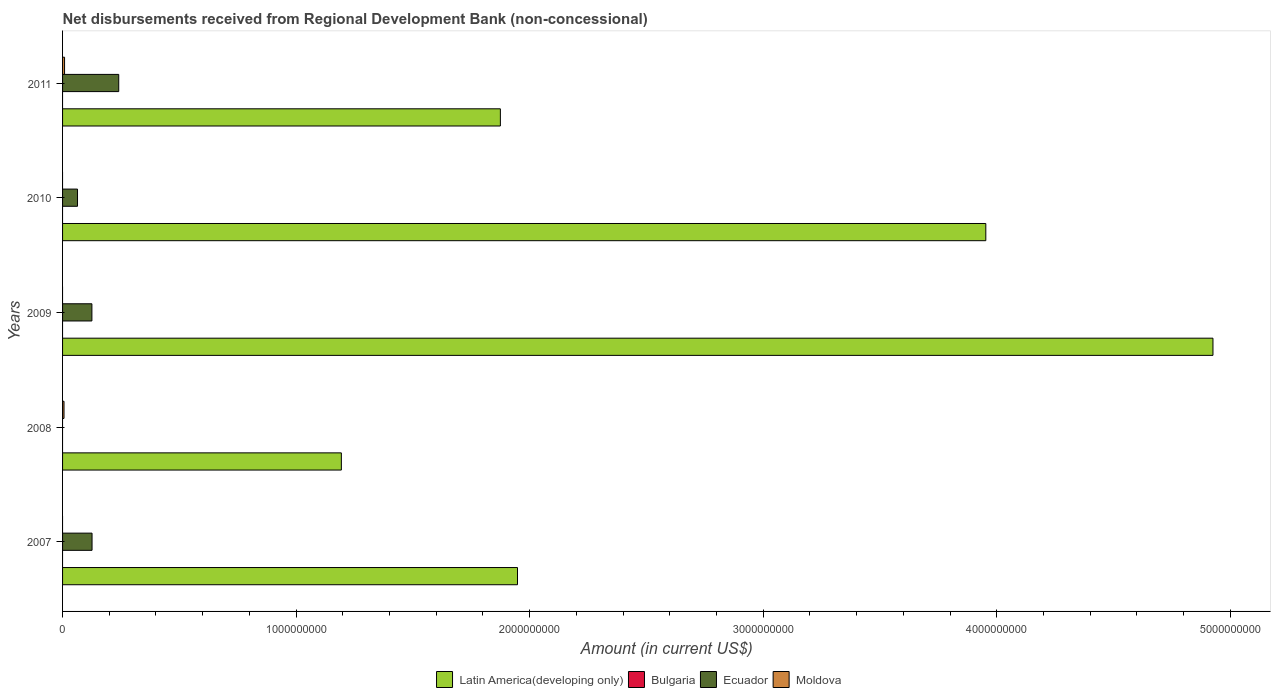How many groups of bars are there?
Ensure brevity in your answer.  5. Are the number of bars per tick equal to the number of legend labels?
Your answer should be compact. No. Are the number of bars on each tick of the Y-axis equal?
Ensure brevity in your answer.  No. How many bars are there on the 1st tick from the top?
Ensure brevity in your answer.  3. What is the label of the 1st group of bars from the top?
Your response must be concise. 2011. In how many cases, is the number of bars for a given year not equal to the number of legend labels?
Offer a terse response. 5. Across all years, what is the maximum amount of disbursements received from Regional Development Bank in Ecuador?
Your response must be concise. 2.41e+08. In which year was the amount of disbursements received from Regional Development Bank in Moldova maximum?
Provide a short and direct response. 2011. What is the difference between the amount of disbursements received from Regional Development Bank in Ecuador in 2010 and that in 2011?
Your response must be concise. -1.77e+08. What is the difference between the amount of disbursements received from Regional Development Bank in Ecuador in 2009 and the amount of disbursements received from Regional Development Bank in Moldova in 2011?
Provide a short and direct response. 1.17e+08. What is the average amount of disbursements received from Regional Development Bank in Ecuador per year?
Ensure brevity in your answer.  1.11e+08. In the year 2009, what is the difference between the amount of disbursements received from Regional Development Bank in Ecuador and amount of disbursements received from Regional Development Bank in Latin America(developing only)?
Provide a short and direct response. -4.80e+09. In how many years, is the amount of disbursements received from Regional Development Bank in Ecuador greater than 400000000 US$?
Ensure brevity in your answer.  0. What is the ratio of the amount of disbursements received from Regional Development Bank in Latin America(developing only) in 2008 to that in 2010?
Your answer should be compact. 0.3. Is the amount of disbursements received from Regional Development Bank in Latin America(developing only) in 2008 less than that in 2010?
Ensure brevity in your answer.  Yes. Is the difference between the amount of disbursements received from Regional Development Bank in Ecuador in 2007 and 2011 greater than the difference between the amount of disbursements received from Regional Development Bank in Latin America(developing only) in 2007 and 2011?
Provide a short and direct response. No. What is the difference between the highest and the second highest amount of disbursements received from Regional Development Bank in Ecuador?
Provide a succinct answer. 1.14e+08. What is the difference between the highest and the lowest amount of disbursements received from Regional Development Bank in Moldova?
Your response must be concise. 8.57e+06. In how many years, is the amount of disbursements received from Regional Development Bank in Bulgaria greater than the average amount of disbursements received from Regional Development Bank in Bulgaria taken over all years?
Offer a very short reply. 0. Is it the case that in every year, the sum of the amount of disbursements received from Regional Development Bank in Latin America(developing only) and amount of disbursements received from Regional Development Bank in Moldova is greater than the amount of disbursements received from Regional Development Bank in Ecuador?
Offer a very short reply. Yes. Are all the bars in the graph horizontal?
Keep it short and to the point. Yes. What is the difference between two consecutive major ticks on the X-axis?
Provide a short and direct response. 1.00e+09. Are the values on the major ticks of X-axis written in scientific E-notation?
Give a very brief answer. No. Does the graph contain any zero values?
Give a very brief answer. Yes. Where does the legend appear in the graph?
Your answer should be very brief. Bottom center. How many legend labels are there?
Your response must be concise. 4. How are the legend labels stacked?
Keep it short and to the point. Horizontal. What is the title of the graph?
Provide a short and direct response. Net disbursements received from Regional Development Bank (non-concessional). Does "Arab World" appear as one of the legend labels in the graph?
Your answer should be very brief. No. What is the label or title of the X-axis?
Provide a short and direct response. Amount (in current US$). What is the label or title of the Y-axis?
Offer a very short reply. Years. What is the Amount (in current US$) in Latin America(developing only) in 2007?
Your answer should be very brief. 1.95e+09. What is the Amount (in current US$) of Bulgaria in 2007?
Ensure brevity in your answer.  0. What is the Amount (in current US$) in Ecuador in 2007?
Provide a short and direct response. 1.26e+08. What is the Amount (in current US$) in Latin America(developing only) in 2008?
Make the answer very short. 1.19e+09. What is the Amount (in current US$) in Ecuador in 2008?
Make the answer very short. 0. What is the Amount (in current US$) in Moldova in 2008?
Ensure brevity in your answer.  6.18e+06. What is the Amount (in current US$) in Latin America(developing only) in 2009?
Your response must be concise. 4.93e+09. What is the Amount (in current US$) in Bulgaria in 2009?
Offer a terse response. 0. What is the Amount (in current US$) of Ecuador in 2009?
Make the answer very short. 1.26e+08. What is the Amount (in current US$) in Latin America(developing only) in 2010?
Ensure brevity in your answer.  3.95e+09. What is the Amount (in current US$) in Bulgaria in 2010?
Your answer should be compact. 0. What is the Amount (in current US$) of Ecuador in 2010?
Provide a short and direct response. 6.40e+07. What is the Amount (in current US$) in Moldova in 2010?
Provide a succinct answer. 0. What is the Amount (in current US$) in Latin America(developing only) in 2011?
Offer a terse response. 1.87e+09. What is the Amount (in current US$) in Bulgaria in 2011?
Ensure brevity in your answer.  0. What is the Amount (in current US$) of Ecuador in 2011?
Give a very brief answer. 2.41e+08. What is the Amount (in current US$) of Moldova in 2011?
Provide a short and direct response. 8.57e+06. Across all years, what is the maximum Amount (in current US$) in Latin America(developing only)?
Offer a very short reply. 4.93e+09. Across all years, what is the maximum Amount (in current US$) in Ecuador?
Give a very brief answer. 2.41e+08. Across all years, what is the maximum Amount (in current US$) in Moldova?
Provide a succinct answer. 8.57e+06. Across all years, what is the minimum Amount (in current US$) of Latin America(developing only)?
Provide a short and direct response. 1.19e+09. Across all years, what is the minimum Amount (in current US$) of Ecuador?
Your answer should be very brief. 0. What is the total Amount (in current US$) in Latin America(developing only) in the graph?
Your response must be concise. 1.39e+1. What is the total Amount (in current US$) in Ecuador in the graph?
Your response must be concise. 5.56e+08. What is the total Amount (in current US$) in Moldova in the graph?
Give a very brief answer. 1.48e+07. What is the difference between the Amount (in current US$) of Latin America(developing only) in 2007 and that in 2008?
Provide a short and direct response. 7.54e+08. What is the difference between the Amount (in current US$) in Latin America(developing only) in 2007 and that in 2009?
Make the answer very short. -2.98e+09. What is the difference between the Amount (in current US$) of Ecuador in 2007 and that in 2009?
Provide a short and direct response. 6.24e+05. What is the difference between the Amount (in current US$) of Latin America(developing only) in 2007 and that in 2010?
Keep it short and to the point. -2.01e+09. What is the difference between the Amount (in current US$) in Ecuador in 2007 and that in 2010?
Your answer should be very brief. 6.23e+07. What is the difference between the Amount (in current US$) of Latin America(developing only) in 2007 and that in 2011?
Keep it short and to the point. 7.34e+07. What is the difference between the Amount (in current US$) of Ecuador in 2007 and that in 2011?
Your answer should be very brief. -1.14e+08. What is the difference between the Amount (in current US$) in Latin America(developing only) in 2008 and that in 2009?
Offer a very short reply. -3.73e+09. What is the difference between the Amount (in current US$) in Latin America(developing only) in 2008 and that in 2010?
Your answer should be very brief. -2.76e+09. What is the difference between the Amount (in current US$) of Latin America(developing only) in 2008 and that in 2011?
Ensure brevity in your answer.  -6.81e+08. What is the difference between the Amount (in current US$) of Moldova in 2008 and that in 2011?
Provide a short and direct response. -2.38e+06. What is the difference between the Amount (in current US$) in Latin America(developing only) in 2009 and that in 2010?
Your answer should be very brief. 9.73e+08. What is the difference between the Amount (in current US$) of Ecuador in 2009 and that in 2010?
Give a very brief answer. 6.16e+07. What is the difference between the Amount (in current US$) of Latin America(developing only) in 2009 and that in 2011?
Offer a terse response. 3.05e+09. What is the difference between the Amount (in current US$) in Ecuador in 2009 and that in 2011?
Your answer should be very brief. -1.15e+08. What is the difference between the Amount (in current US$) in Latin America(developing only) in 2010 and that in 2011?
Offer a terse response. 2.08e+09. What is the difference between the Amount (in current US$) of Ecuador in 2010 and that in 2011?
Make the answer very short. -1.77e+08. What is the difference between the Amount (in current US$) in Latin America(developing only) in 2007 and the Amount (in current US$) in Moldova in 2008?
Make the answer very short. 1.94e+09. What is the difference between the Amount (in current US$) of Ecuador in 2007 and the Amount (in current US$) of Moldova in 2008?
Your answer should be very brief. 1.20e+08. What is the difference between the Amount (in current US$) in Latin America(developing only) in 2007 and the Amount (in current US$) in Ecuador in 2009?
Your answer should be compact. 1.82e+09. What is the difference between the Amount (in current US$) of Latin America(developing only) in 2007 and the Amount (in current US$) of Ecuador in 2010?
Your answer should be compact. 1.88e+09. What is the difference between the Amount (in current US$) of Latin America(developing only) in 2007 and the Amount (in current US$) of Ecuador in 2011?
Ensure brevity in your answer.  1.71e+09. What is the difference between the Amount (in current US$) in Latin America(developing only) in 2007 and the Amount (in current US$) in Moldova in 2011?
Provide a succinct answer. 1.94e+09. What is the difference between the Amount (in current US$) of Ecuador in 2007 and the Amount (in current US$) of Moldova in 2011?
Provide a succinct answer. 1.18e+08. What is the difference between the Amount (in current US$) of Latin America(developing only) in 2008 and the Amount (in current US$) of Ecuador in 2009?
Make the answer very short. 1.07e+09. What is the difference between the Amount (in current US$) of Latin America(developing only) in 2008 and the Amount (in current US$) of Ecuador in 2010?
Keep it short and to the point. 1.13e+09. What is the difference between the Amount (in current US$) of Latin America(developing only) in 2008 and the Amount (in current US$) of Ecuador in 2011?
Your answer should be very brief. 9.53e+08. What is the difference between the Amount (in current US$) of Latin America(developing only) in 2008 and the Amount (in current US$) of Moldova in 2011?
Ensure brevity in your answer.  1.19e+09. What is the difference between the Amount (in current US$) of Latin America(developing only) in 2009 and the Amount (in current US$) of Ecuador in 2010?
Give a very brief answer. 4.86e+09. What is the difference between the Amount (in current US$) of Latin America(developing only) in 2009 and the Amount (in current US$) of Ecuador in 2011?
Provide a succinct answer. 4.69e+09. What is the difference between the Amount (in current US$) in Latin America(developing only) in 2009 and the Amount (in current US$) in Moldova in 2011?
Your answer should be very brief. 4.92e+09. What is the difference between the Amount (in current US$) in Ecuador in 2009 and the Amount (in current US$) in Moldova in 2011?
Offer a very short reply. 1.17e+08. What is the difference between the Amount (in current US$) in Latin America(developing only) in 2010 and the Amount (in current US$) in Ecuador in 2011?
Provide a succinct answer. 3.71e+09. What is the difference between the Amount (in current US$) of Latin America(developing only) in 2010 and the Amount (in current US$) of Moldova in 2011?
Provide a short and direct response. 3.94e+09. What is the difference between the Amount (in current US$) in Ecuador in 2010 and the Amount (in current US$) in Moldova in 2011?
Your answer should be very brief. 5.54e+07. What is the average Amount (in current US$) in Latin America(developing only) per year?
Your response must be concise. 2.78e+09. What is the average Amount (in current US$) in Bulgaria per year?
Your response must be concise. 0. What is the average Amount (in current US$) in Ecuador per year?
Offer a terse response. 1.11e+08. What is the average Amount (in current US$) of Moldova per year?
Give a very brief answer. 2.95e+06. In the year 2007, what is the difference between the Amount (in current US$) of Latin America(developing only) and Amount (in current US$) of Ecuador?
Your answer should be very brief. 1.82e+09. In the year 2008, what is the difference between the Amount (in current US$) of Latin America(developing only) and Amount (in current US$) of Moldova?
Offer a very short reply. 1.19e+09. In the year 2009, what is the difference between the Amount (in current US$) of Latin America(developing only) and Amount (in current US$) of Ecuador?
Ensure brevity in your answer.  4.80e+09. In the year 2010, what is the difference between the Amount (in current US$) of Latin America(developing only) and Amount (in current US$) of Ecuador?
Offer a very short reply. 3.89e+09. In the year 2011, what is the difference between the Amount (in current US$) of Latin America(developing only) and Amount (in current US$) of Ecuador?
Provide a short and direct response. 1.63e+09. In the year 2011, what is the difference between the Amount (in current US$) in Latin America(developing only) and Amount (in current US$) in Moldova?
Your answer should be compact. 1.87e+09. In the year 2011, what is the difference between the Amount (in current US$) in Ecuador and Amount (in current US$) in Moldova?
Provide a short and direct response. 2.32e+08. What is the ratio of the Amount (in current US$) in Latin America(developing only) in 2007 to that in 2008?
Offer a terse response. 1.63. What is the ratio of the Amount (in current US$) of Latin America(developing only) in 2007 to that in 2009?
Ensure brevity in your answer.  0.4. What is the ratio of the Amount (in current US$) in Latin America(developing only) in 2007 to that in 2010?
Keep it short and to the point. 0.49. What is the ratio of the Amount (in current US$) of Ecuador in 2007 to that in 2010?
Provide a succinct answer. 1.97. What is the ratio of the Amount (in current US$) of Latin America(developing only) in 2007 to that in 2011?
Offer a very short reply. 1.04. What is the ratio of the Amount (in current US$) of Ecuador in 2007 to that in 2011?
Keep it short and to the point. 0.53. What is the ratio of the Amount (in current US$) in Latin America(developing only) in 2008 to that in 2009?
Offer a terse response. 0.24. What is the ratio of the Amount (in current US$) of Latin America(developing only) in 2008 to that in 2010?
Offer a terse response. 0.3. What is the ratio of the Amount (in current US$) in Latin America(developing only) in 2008 to that in 2011?
Ensure brevity in your answer.  0.64. What is the ratio of the Amount (in current US$) of Moldova in 2008 to that in 2011?
Your response must be concise. 0.72. What is the ratio of the Amount (in current US$) of Latin America(developing only) in 2009 to that in 2010?
Offer a very short reply. 1.25. What is the ratio of the Amount (in current US$) in Ecuador in 2009 to that in 2010?
Your answer should be compact. 1.96. What is the ratio of the Amount (in current US$) in Latin America(developing only) in 2009 to that in 2011?
Your response must be concise. 2.63. What is the ratio of the Amount (in current US$) in Ecuador in 2009 to that in 2011?
Provide a short and direct response. 0.52. What is the ratio of the Amount (in current US$) in Latin America(developing only) in 2010 to that in 2011?
Provide a short and direct response. 2.11. What is the ratio of the Amount (in current US$) of Ecuador in 2010 to that in 2011?
Your answer should be very brief. 0.27. What is the difference between the highest and the second highest Amount (in current US$) in Latin America(developing only)?
Provide a succinct answer. 9.73e+08. What is the difference between the highest and the second highest Amount (in current US$) in Ecuador?
Ensure brevity in your answer.  1.14e+08. What is the difference between the highest and the lowest Amount (in current US$) of Latin America(developing only)?
Your answer should be very brief. 3.73e+09. What is the difference between the highest and the lowest Amount (in current US$) in Ecuador?
Keep it short and to the point. 2.41e+08. What is the difference between the highest and the lowest Amount (in current US$) of Moldova?
Ensure brevity in your answer.  8.57e+06. 